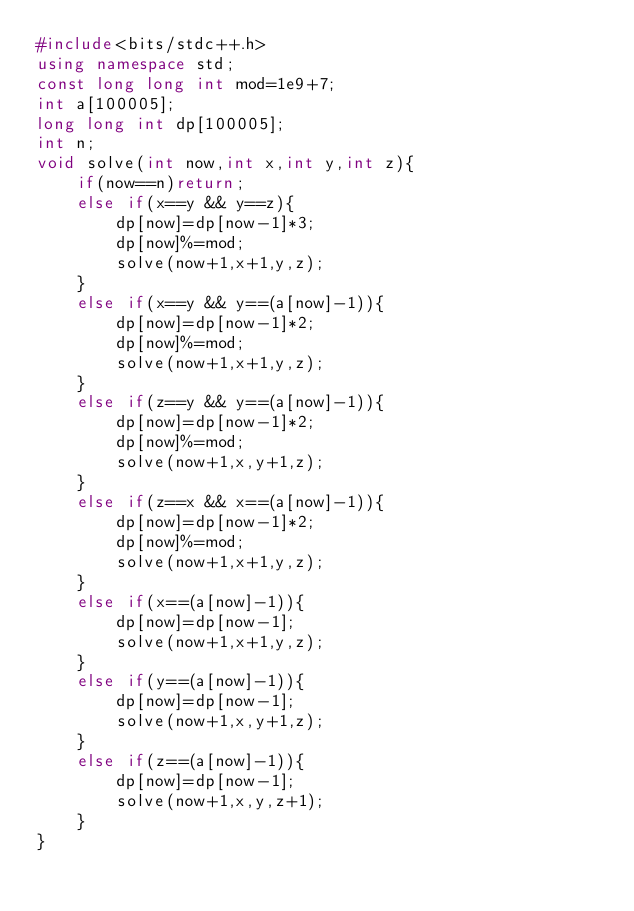Convert code to text. <code><loc_0><loc_0><loc_500><loc_500><_C++_>#include<bits/stdc++.h>
using namespace std;
const long long int mod=1e9+7;
int a[100005];
long long int dp[100005];
int n;
void solve(int now,int x,int y,int z){
    if(now==n)return;
    else if(x==y && y==z){
        dp[now]=dp[now-1]*3;
        dp[now]%=mod;
        solve(now+1,x+1,y,z);
    }
    else if(x==y && y==(a[now]-1)){
        dp[now]=dp[now-1]*2;
        dp[now]%=mod;
        solve(now+1,x+1,y,z);        
    }
    else if(z==y && y==(a[now]-1)){
        dp[now]=dp[now-1]*2;
        dp[now]%=mod;
        solve(now+1,x,y+1,z);        
    }
    else if(z==x && x==(a[now]-1)){
        dp[now]=dp[now-1]*2;
        dp[now]%=mod;
        solve(now+1,x+1,y,z);        
    }
    else if(x==(a[now]-1)){
        dp[now]=dp[now-1];
        solve(now+1,x+1,y,z);
    }
    else if(y==(a[now]-1)){
        dp[now]=dp[now-1];
        solve(now+1,x,y+1,z);
    }
    else if(z==(a[now]-1)){
        dp[now]=dp[now-1];
        solve(now+1,x,y,z+1);
    }
}</code> 